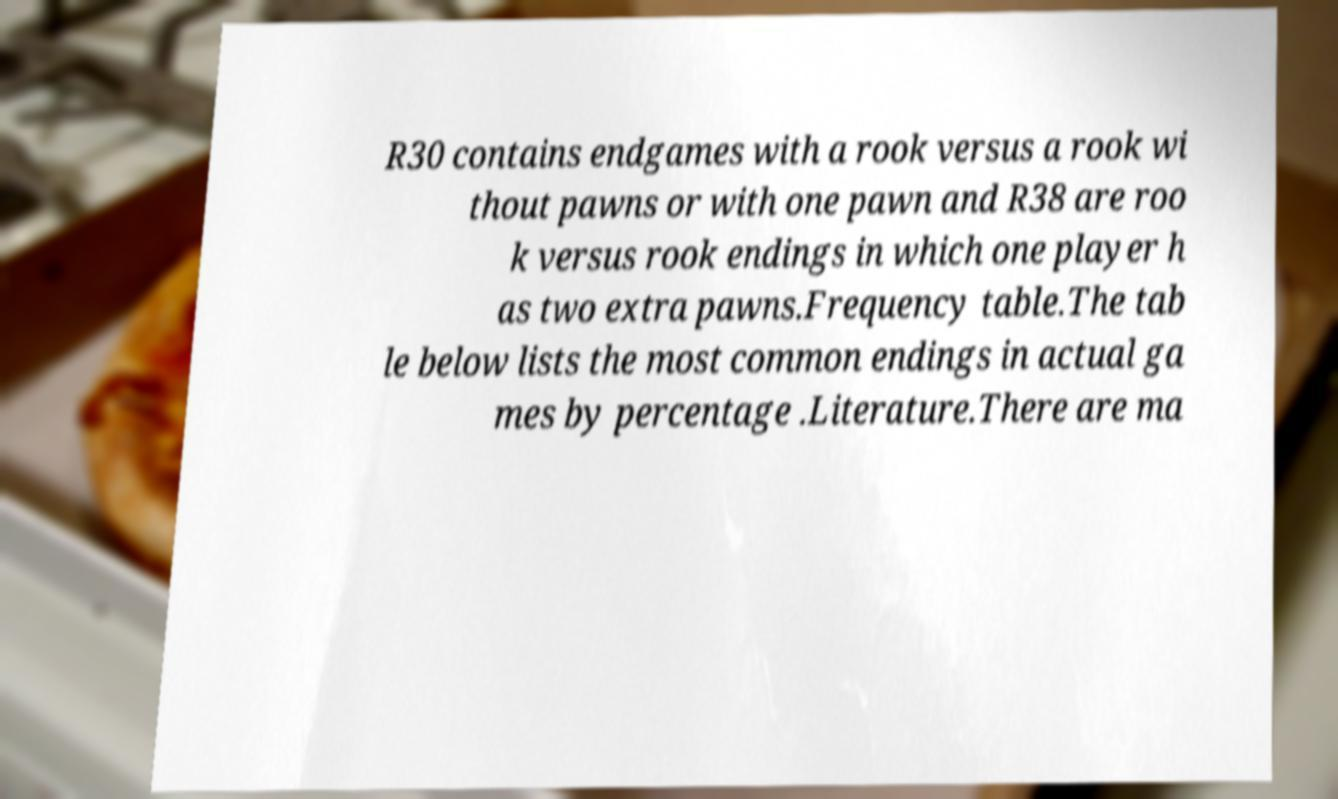What messages or text are displayed in this image? I need them in a readable, typed format. R30 contains endgames with a rook versus a rook wi thout pawns or with one pawn and R38 are roo k versus rook endings in which one player h as two extra pawns.Frequency table.The tab le below lists the most common endings in actual ga mes by percentage .Literature.There are ma 